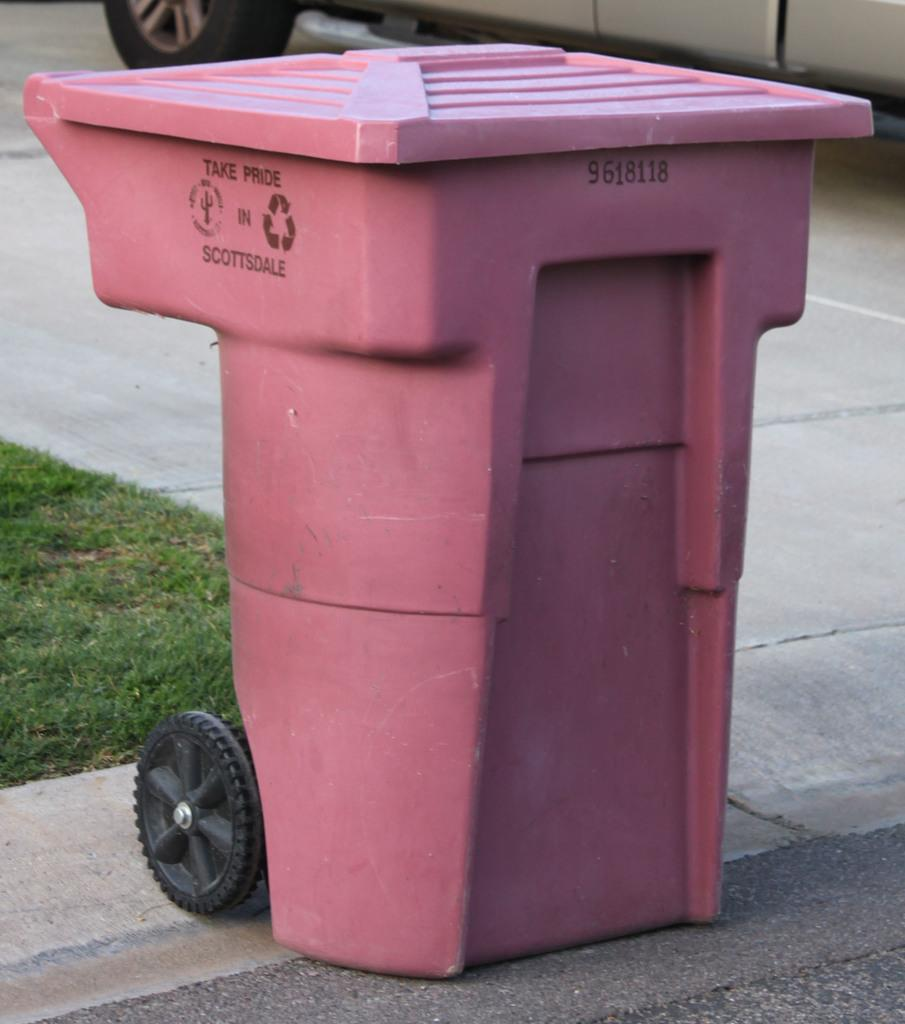<image>
Summarize the visual content of the image. a trash can that says take pride on it 